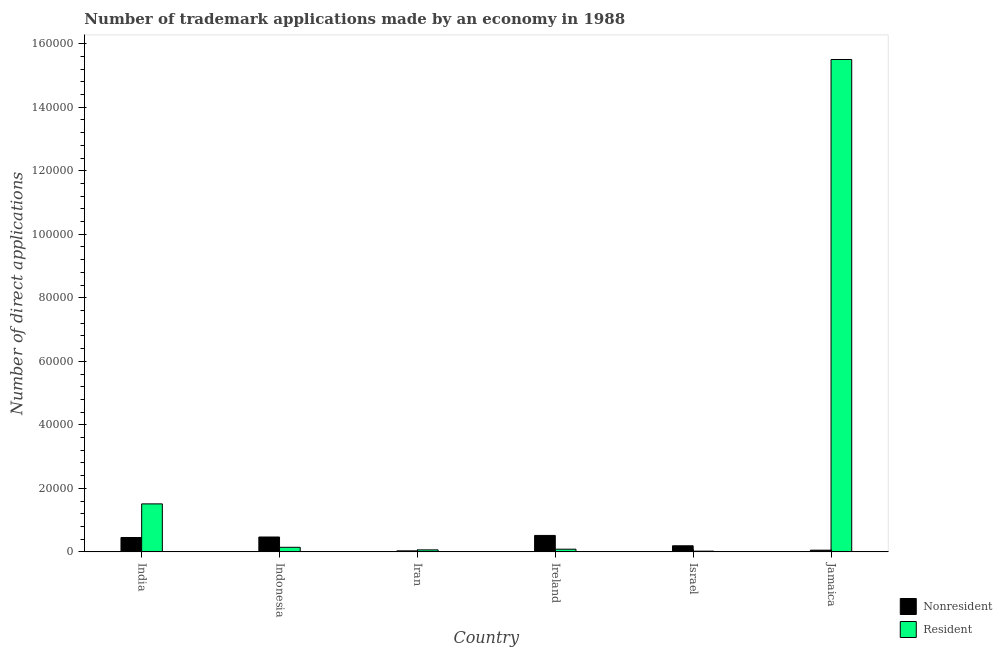How many different coloured bars are there?
Keep it short and to the point. 2. How many groups of bars are there?
Your answer should be compact. 6. Are the number of bars per tick equal to the number of legend labels?
Ensure brevity in your answer.  Yes. Are the number of bars on each tick of the X-axis equal?
Your answer should be compact. Yes. What is the label of the 4th group of bars from the left?
Provide a succinct answer. Ireland. In how many cases, is the number of bars for a given country not equal to the number of legend labels?
Provide a short and direct response. 0. What is the number of trademark applications made by non residents in Iran?
Make the answer very short. 318. Across all countries, what is the maximum number of trademark applications made by non residents?
Offer a terse response. 5177. Across all countries, what is the minimum number of trademark applications made by residents?
Provide a succinct answer. 227. In which country was the number of trademark applications made by non residents maximum?
Make the answer very short. Ireland. In which country was the number of trademark applications made by non residents minimum?
Offer a terse response. Iran. What is the total number of trademark applications made by non residents in the graph?
Give a very brief answer. 1.72e+04. What is the difference between the number of trademark applications made by residents in Indonesia and that in Ireland?
Ensure brevity in your answer.  596. What is the difference between the number of trademark applications made by residents in Indonesia and the number of trademark applications made by non residents in Ireland?
Offer a terse response. -3738. What is the average number of trademark applications made by residents per country?
Your response must be concise. 2.89e+04. What is the difference between the number of trademark applications made by non residents and number of trademark applications made by residents in Iran?
Ensure brevity in your answer.  -309. In how many countries, is the number of trademark applications made by non residents greater than 20000 ?
Make the answer very short. 0. What is the ratio of the number of trademark applications made by non residents in India to that in Jamaica?
Give a very brief answer. 8.45. Is the difference between the number of trademark applications made by residents in India and Israel greater than the difference between the number of trademark applications made by non residents in India and Israel?
Provide a short and direct response. Yes. What is the difference between the highest and the second highest number of trademark applications made by residents?
Your answer should be very brief. 1.40e+05. What is the difference between the highest and the lowest number of trademark applications made by residents?
Offer a terse response. 1.55e+05. In how many countries, is the number of trademark applications made by residents greater than the average number of trademark applications made by residents taken over all countries?
Offer a terse response. 1. Is the sum of the number of trademark applications made by non residents in Iran and Israel greater than the maximum number of trademark applications made by residents across all countries?
Keep it short and to the point. No. What does the 2nd bar from the left in Iran represents?
Keep it short and to the point. Resident. What does the 1st bar from the right in Iran represents?
Provide a succinct answer. Resident. How many bars are there?
Offer a terse response. 12. Are all the bars in the graph horizontal?
Give a very brief answer. No. How many countries are there in the graph?
Offer a terse response. 6. Does the graph contain any zero values?
Your answer should be compact. No. Does the graph contain grids?
Offer a terse response. No. Where does the legend appear in the graph?
Make the answer very short. Bottom right. What is the title of the graph?
Give a very brief answer. Number of trademark applications made by an economy in 1988. What is the label or title of the Y-axis?
Your response must be concise. Number of direct applications. What is the Number of direct applications of Nonresident in India?
Give a very brief answer. 4523. What is the Number of direct applications in Resident in India?
Your answer should be compact. 1.51e+04. What is the Number of direct applications in Nonresident in Indonesia?
Provide a succinct answer. 4682. What is the Number of direct applications in Resident in Indonesia?
Your response must be concise. 1439. What is the Number of direct applications of Nonresident in Iran?
Make the answer very short. 318. What is the Number of direct applications in Resident in Iran?
Make the answer very short. 627. What is the Number of direct applications in Nonresident in Ireland?
Your answer should be compact. 5177. What is the Number of direct applications in Resident in Ireland?
Give a very brief answer. 843. What is the Number of direct applications of Nonresident in Israel?
Your response must be concise. 1915. What is the Number of direct applications in Resident in Israel?
Make the answer very short. 227. What is the Number of direct applications of Nonresident in Jamaica?
Offer a terse response. 535. What is the Number of direct applications of Resident in Jamaica?
Ensure brevity in your answer.  1.55e+05. Across all countries, what is the maximum Number of direct applications in Nonresident?
Provide a short and direct response. 5177. Across all countries, what is the maximum Number of direct applications in Resident?
Your answer should be very brief. 1.55e+05. Across all countries, what is the minimum Number of direct applications of Nonresident?
Provide a succinct answer. 318. Across all countries, what is the minimum Number of direct applications in Resident?
Offer a terse response. 227. What is the total Number of direct applications of Nonresident in the graph?
Make the answer very short. 1.72e+04. What is the total Number of direct applications of Resident in the graph?
Keep it short and to the point. 1.73e+05. What is the difference between the Number of direct applications in Nonresident in India and that in Indonesia?
Provide a short and direct response. -159. What is the difference between the Number of direct applications in Resident in India and that in Indonesia?
Provide a succinct answer. 1.37e+04. What is the difference between the Number of direct applications in Nonresident in India and that in Iran?
Provide a succinct answer. 4205. What is the difference between the Number of direct applications in Resident in India and that in Iran?
Offer a very short reply. 1.45e+04. What is the difference between the Number of direct applications in Nonresident in India and that in Ireland?
Your response must be concise. -654. What is the difference between the Number of direct applications of Resident in India and that in Ireland?
Keep it short and to the point. 1.43e+04. What is the difference between the Number of direct applications in Nonresident in India and that in Israel?
Ensure brevity in your answer.  2608. What is the difference between the Number of direct applications in Resident in India and that in Israel?
Offer a terse response. 1.49e+04. What is the difference between the Number of direct applications of Nonresident in India and that in Jamaica?
Provide a succinct answer. 3988. What is the difference between the Number of direct applications of Resident in India and that in Jamaica?
Provide a succinct answer. -1.40e+05. What is the difference between the Number of direct applications in Nonresident in Indonesia and that in Iran?
Give a very brief answer. 4364. What is the difference between the Number of direct applications in Resident in Indonesia and that in Iran?
Ensure brevity in your answer.  812. What is the difference between the Number of direct applications in Nonresident in Indonesia and that in Ireland?
Your response must be concise. -495. What is the difference between the Number of direct applications in Resident in Indonesia and that in Ireland?
Your answer should be compact. 596. What is the difference between the Number of direct applications of Nonresident in Indonesia and that in Israel?
Give a very brief answer. 2767. What is the difference between the Number of direct applications in Resident in Indonesia and that in Israel?
Provide a short and direct response. 1212. What is the difference between the Number of direct applications in Nonresident in Indonesia and that in Jamaica?
Provide a short and direct response. 4147. What is the difference between the Number of direct applications of Resident in Indonesia and that in Jamaica?
Make the answer very short. -1.54e+05. What is the difference between the Number of direct applications in Nonresident in Iran and that in Ireland?
Offer a terse response. -4859. What is the difference between the Number of direct applications in Resident in Iran and that in Ireland?
Your response must be concise. -216. What is the difference between the Number of direct applications in Nonresident in Iran and that in Israel?
Offer a very short reply. -1597. What is the difference between the Number of direct applications of Nonresident in Iran and that in Jamaica?
Keep it short and to the point. -217. What is the difference between the Number of direct applications in Resident in Iran and that in Jamaica?
Your answer should be very brief. -1.54e+05. What is the difference between the Number of direct applications in Nonresident in Ireland and that in Israel?
Make the answer very short. 3262. What is the difference between the Number of direct applications of Resident in Ireland and that in Israel?
Offer a very short reply. 616. What is the difference between the Number of direct applications of Nonresident in Ireland and that in Jamaica?
Make the answer very short. 4642. What is the difference between the Number of direct applications in Resident in Ireland and that in Jamaica?
Provide a short and direct response. -1.54e+05. What is the difference between the Number of direct applications of Nonresident in Israel and that in Jamaica?
Give a very brief answer. 1380. What is the difference between the Number of direct applications of Resident in Israel and that in Jamaica?
Provide a succinct answer. -1.55e+05. What is the difference between the Number of direct applications in Nonresident in India and the Number of direct applications in Resident in Indonesia?
Make the answer very short. 3084. What is the difference between the Number of direct applications in Nonresident in India and the Number of direct applications in Resident in Iran?
Provide a short and direct response. 3896. What is the difference between the Number of direct applications of Nonresident in India and the Number of direct applications of Resident in Ireland?
Your answer should be very brief. 3680. What is the difference between the Number of direct applications in Nonresident in India and the Number of direct applications in Resident in Israel?
Make the answer very short. 4296. What is the difference between the Number of direct applications in Nonresident in India and the Number of direct applications in Resident in Jamaica?
Offer a terse response. -1.51e+05. What is the difference between the Number of direct applications of Nonresident in Indonesia and the Number of direct applications of Resident in Iran?
Give a very brief answer. 4055. What is the difference between the Number of direct applications in Nonresident in Indonesia and the Number of direct applications in Resident in Ireland?
Ensure brevity in your answer.  3839. What is the difference between the Number of direct applications of Nonresident in Indonesia and the Number of direct applications of Resident in Israel?
Give a very brief answer. 4455. What is the difference between the Number of direct applications of Nonresident in Indonesia and the Number of direct applications of Resident in Jamaica?
Your answer should be very brief. -1.50e+05. What is the difference between the Number of direct applications in Nonresident in Iran and the Number of direct applications in Resident in Ireland?
Your response must be concise. -525. What is the difference between the Number of direct applications in Nonresident in Iran and the Number of direct applications in Resident in Israel?
Provide a succinct answer. 91. What is the difference between the Number of direct applications in Nonresident in Iran and the Number of direct applications in Resident in Jamaica?
Provide a succinct answer. -1.55e+05. What is the difference between the Number of direct applications in Nonresident in Ireland and the Number of direct applications in Resident in Israel?
Your response must be concise. 4950. What is the difference between the Number of direct applications of Nonresident in Ireland and the Number of direct applications of Resident in Jamaica?
Offer a very short reply. -1.50e+05. What is the difference between the Number of direct applications in Nonresident in Israel and the Number of direct applications in Resident in Jamaica?
Your answer should be compact. -1.53e+05. What is the average Number of direct applications of Nonresident per country?
Make the answer very short. 2858.33. What is the average Number of direct applications in Resident per country?
Give a very brief answer. 2.89e+04. What is the difference between the Number of direct applications of Nonresident and Number of direct applications of Resident in India?
Ensure brevity in your answer.  -1.06e+04. What is the difference between the Number of direct applications in Nonresident and Number of direct applications in Resident in Indonesia?
Ensure brevity in your answer.  3243. What is the difference between the Number of direct applications of Nonresident and Number of direct applications of Resident in Iran?
Give a very brief answer. -309. What is the difference between the Number of direct applications in Nonresident and Number of direct applications in Resident in Ireland?
Provide a short and direct response. 4334. What is the difference between the Number of direct applications in Nonresident and Number of direct applications in Resident in Israel?
Offer a terse response. 1688. What is the difference between the Number of direct applications of Nonresident and Number of direct applications of Resident in Jamaica?
Provide a short and direct response. -1.54e+05. What is the ratio of the Number of direct applications in Nonresident in India to that in Indonesia?
Keep it short and to the point. 0.97. What is the ratio of the Number of direct applications of Resident in India to that in Indonesia?
Provide a short and direct response. 10.5. What is the ratio of the Number of direct applications in Nonresident in India to that in Iran?
Offer a terse response. 14.22. What is the ratio of the Number of direct applications in Resident in India to that in Iran?
Offer a terse response. 24.1. What is the ratio of the Number of direct applications of Nonresident in India to that in Ireland?
Your answer should be compact. 0.87. What is the ratio of the Number of direct applications in Resident in India to that in Ireland?
Provide a short and direct response. 17.92. What is the ratio of the Number of direct applications in Nonresident in India to that in Israel?
Provide a short and direct response. 2.36. What is the ratio of the Number of direct applications of Resident in India to that in Israel?
Make the answer very short. 66.56. What is the ratio of the Number of direct applications of Nonresident in India to that in Jamaica?
Provide a succinct answer. 8.45. What is the ratio of the Number of direct applications of Resident in India to that in Jamaica?
Make the answer very short. 0.1. What is the ratio of the Number of direct applications of Nonresident in Indonesia to that in Iran?
Your answer should be compact. 14.72. What is the ratio of the Number of direct applications of Resident in Indonesia to that in Iran?
Offer a very short reply. 2.3. What is the ratio of the Number of direct applications of Nonresident in Indonesia to that in Ireland?
Give a very brief answer. 0.9. What is the ratio of the Number of direct applications of Resident in Indonesia to that in Ireland?
Make the answer very short. 1.71. What is the ratio of the Number of direct applications in Nonresident in Indonesia to that in Israel?
Ensure brevity in your answer.  2.44. What is the ratio of the Number of direct applications in Resident in Indonesia to that in Israel?
Give a very brief answer. 6.34. What is the ratio of the Number of direct applications of Nonresident in Indonesia to that in Jamaica?
Keep it short and to the point. 8.75. What is the ratio of the Number of direct applications in Resident in Indonesia to that in Jamaica?
Ensure brevity in your answer.  0.01. What is the ratio of the Number of direct applications of Nonresident in Iran to that in Ireland?
Your answer should be very brief. 0.06. What is the ratio of the Number of direct applications of Resident in Iran to that in Ireland?
Your answer should be very brief. 0.74. What is the ratio of the Number of direct applications in Nonresident in Iran to that in Israel?
Keep it short and to the point. 0.17. What is the ratio of the Number of direct applications in Resident in Iran to that in Israel?
Provide a short and direct response. 2.76. What is the ratio of the Number of direct applications of Nonresident in Iran to that in Jamaica?
Your response must be concise. 0.59. What is the ratio of the Number of direct applications in Resident in Iran to that in Jamaica?
Make the answer very short. 0. What is the ratio of the Number of direct applications of Nonresident in Ireland to that in Israel?
Your response must be concise. 2.7. What is the ratio of the Number of direct applications in Resident in Ireland to that in Israel?
Your response must be concise. 3.71. What is the ratio of the Number of direct applications of Nonresident in Ireland to that in Jamaica?
Offer a terse response. 9.68. What is the ratio of the Number of direct applications of Resident in Ireland to that in Jamaica?
Provide a short and direct response. 0.01. What is the ratio of the Number of direct applications in Nonresident in Israel to that in Jamaica?
Keep it short and to the point. 3.58. What is the ratio of the Number of direct applications of Resident in Israel to that in Jamaica?
Offer a very short reply. 0. What is the difference between the highest and the second highest Number of direct applications of Nonresident?
Offer a very short reply. 495. What is the difference between the highest and the second highest Number of direct applications in Resident?
Make the answer very short. 1.40e+05. What is the difference between the highest and the lowest Number of direct applications in Nonresident?
Ensure brevity in your answer.  4859. What is the difference between the highest and the lowest Number of direct applications of Resident?
Offer a terse response. 1.55e+05. 